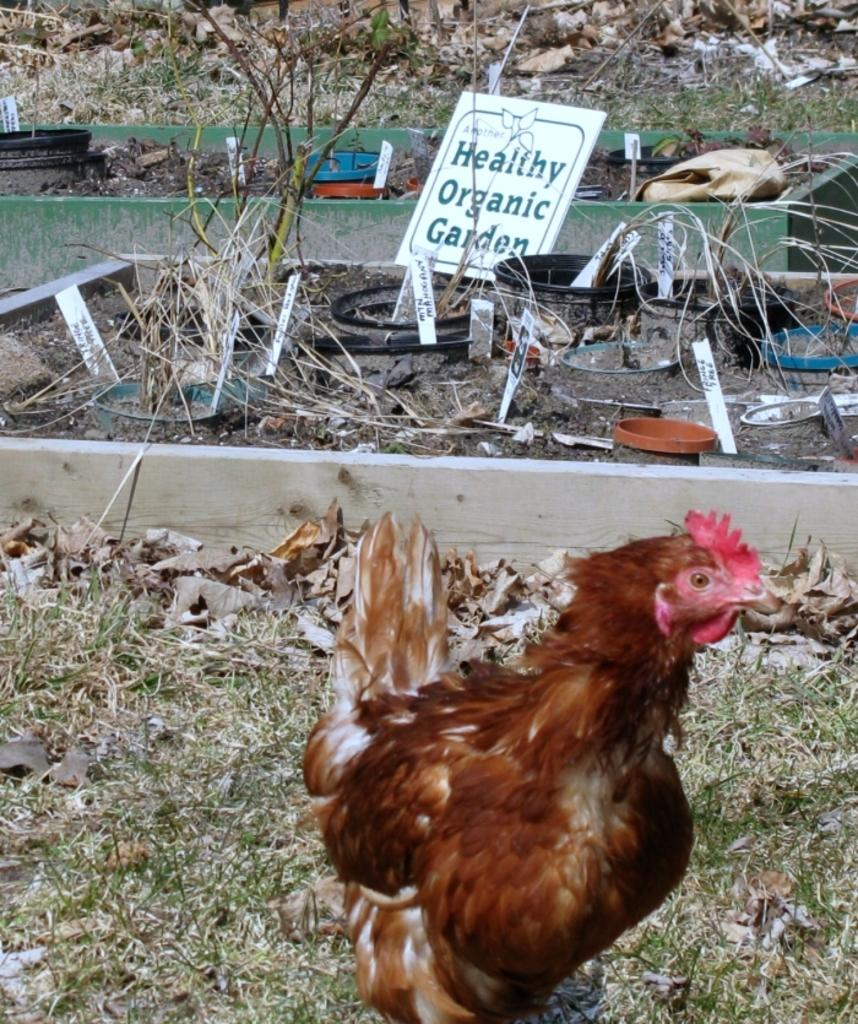What animal is in the foreground of the image? There is a hen in the foreground of the image. What type of vegetation is at the bottom of the image? There is grass at the bottom of the image. What can be seen in the background of the image? There is a board, plants, and other objects in the background of the image. What type of bead is being used to pay the tax in the image? There is no bead or tax mentioned or depicted in the image. 